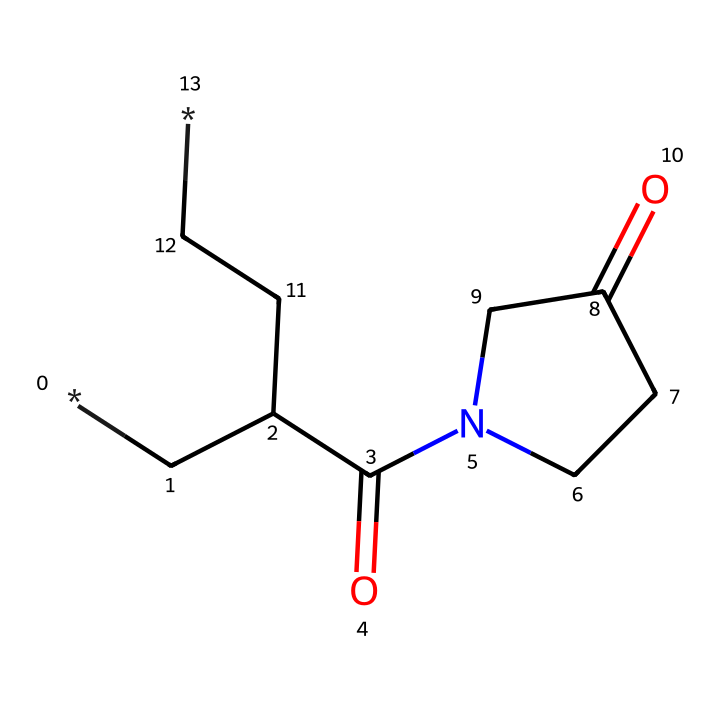How many carbon atoms are present in this chemical? By examining the SMILES representation, I can count the carbon atoms indicated by the letter "C." In this structure, there are six "C" letters, meaning there are six carbon atoms.
Answer: six What type of bond connects the carbon and nitrogen atoms in this chemical? The SMILES representation shows that the carbon atom bonded to the nitrogen atom has a double bond due to the presence of the “=O” after the nitrogen, indicating a carbonyl group.
Answer: double bond What is the main functional group present in this chemical? Looking at the structure, there's a carbonyl group (C=O) and an amide bond (C(=O)N). This indicates that the primary functional group of this compound is the amide functional group.
Answer: amide How many rings are present in the structure of this chemical? The SMILES representation includes a ring structure indicated by the "1" notation. There is one main ring containing four carbon atoms, as the notation shows that the first and last carbons in the sequence are connected to form a closed loop.
Answer: one What is the molecular function of polyvinylpyrrolidone in oral pain relief gels? Polyvinylpyrrolidone primarily acts as a polymer that provides viscosity and stability to the gel and can also enhance the solubility of active ingredients. Thus, its function in the gel enhances the overall effectiveness in pain relief.
Answer: viscosity agent What type of polymer is represented by this chemical structure? The presence of repeating units of the carbon and nitrogen backbone suggests that this is a synthetic polymer, specifically a non-ionic water-soluble polymer.
Answer: synthetic polymer 